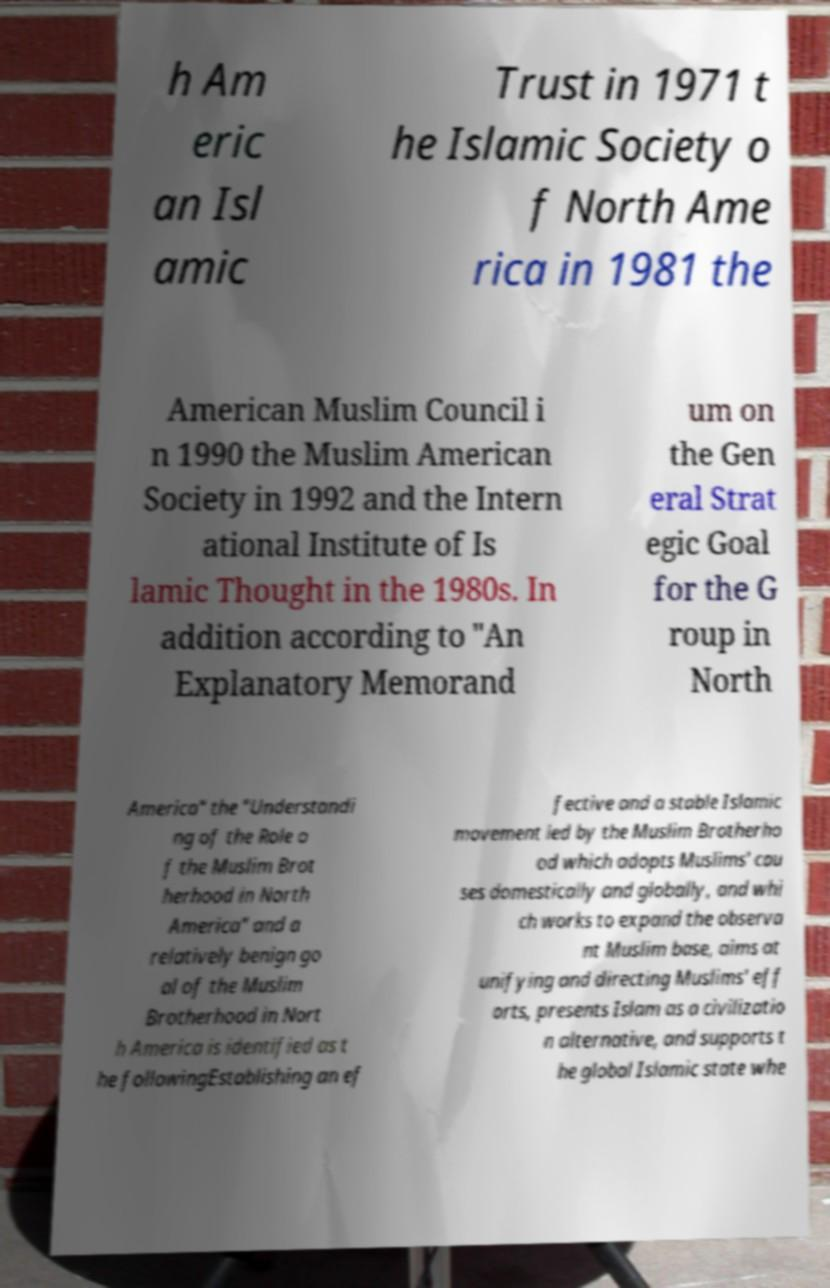What messages or text are displayed in this image? I need them in a readable, typed format. h Am eric an Isl amic Trust in 1971 t he Islamic Society o f North Ame rica in 1981 the American Muslim Council i n 1990 the Muslim American Society in 1992 and the Intern ational Institute of Is lamic Thought in the 1980s. In addition according to "An Explanatory Memorand um on the Gen eral Strat egic Goal for the G roup in North America" the "Understandi ng of the Role o f the Muslim Brot herhood in North America" and a relatively benign go al of the Muslim Brotherhood in Nort h America is identified as t he followingEstablishing an ef fective and a stable Islamic movement led by the Muslim Brotherho od which adopts Muslims' cau ses domestically and globally, and whi ch works to expand the observa nt Muslim base, aims at unifying and directing Muslims' eff orts, presents Islam as a civilizatio n alternative, and supports t he global Islamic state whe 